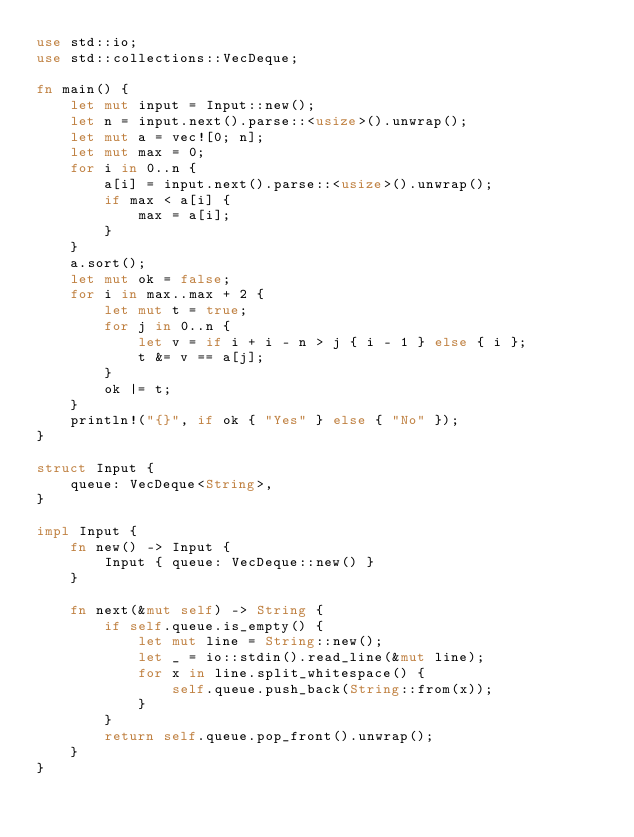Convert code to text. <code><loc_0><loc_0><loc_500><loc_500><_Rust_>use std::io;
use std::collections::VecDeque;

fn main() {
    let mut input = Input::new();
    let n = input.next().parse::<usize>().unwrap();
    let mut a = vec![0; n];
    let mut max = 0;
    for i in 0..n {
        a[i] = input.next().parse::<usize>().unwrap();
        if max < a[i] {
            max = a[i];
        }
    }
    a.sort();
    let mut ok = false;
    for i in max..max + 2 {
        let mut t = true;
        for j in 0..n {
            let v = if i + i - n > j { i - 1 } else { i };
            t &= v == a[j];
        }
        ok |= t;
    }
    println!("{}", if ok { "Yes" } else { "No" });
}

struct Input {
    queue: VecDeque<String>,
}

impl Input {
    fn new() -> Input {
        Input { queue: VecDeque::new() }
    }

    fn next(&mut self) -> String {
        if self.queue.is_empty() {
            let mut line = String::new();
            let _ = io::stdin().read_line(&mut line);
            for x in line.split_whitespace() {
                self.queue.push_back(String::from(x));
            }
        }
        return self.queue.pop_front().unwrap();
    }
}

</code> 